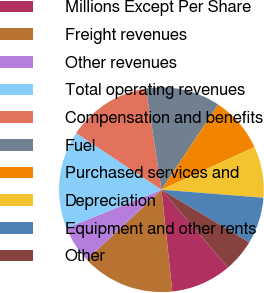Convert chart. <chart><loc_0><loc_0><loc_500><loc_500><pie_chart><fcel>Millions Except Per Share<fcel>Freight revenues<fcel>Other revenues<fcel>Total operating revenues<fcel>Compensation and benefits<fcel>Fuel<fcel>Purchased services and<fcel>Depreciation<fcel>Equipment and other rents<fcel>Other<nl><fcel>9.56%<fcel>14.71%<fcel>5.88%<fcel>15.44%<fcel>13.24%<fcel>11.76%<fcel>8.82%<fcel>8.09%<fcel>7.35%<fcel>5.15%<nl></chart> 